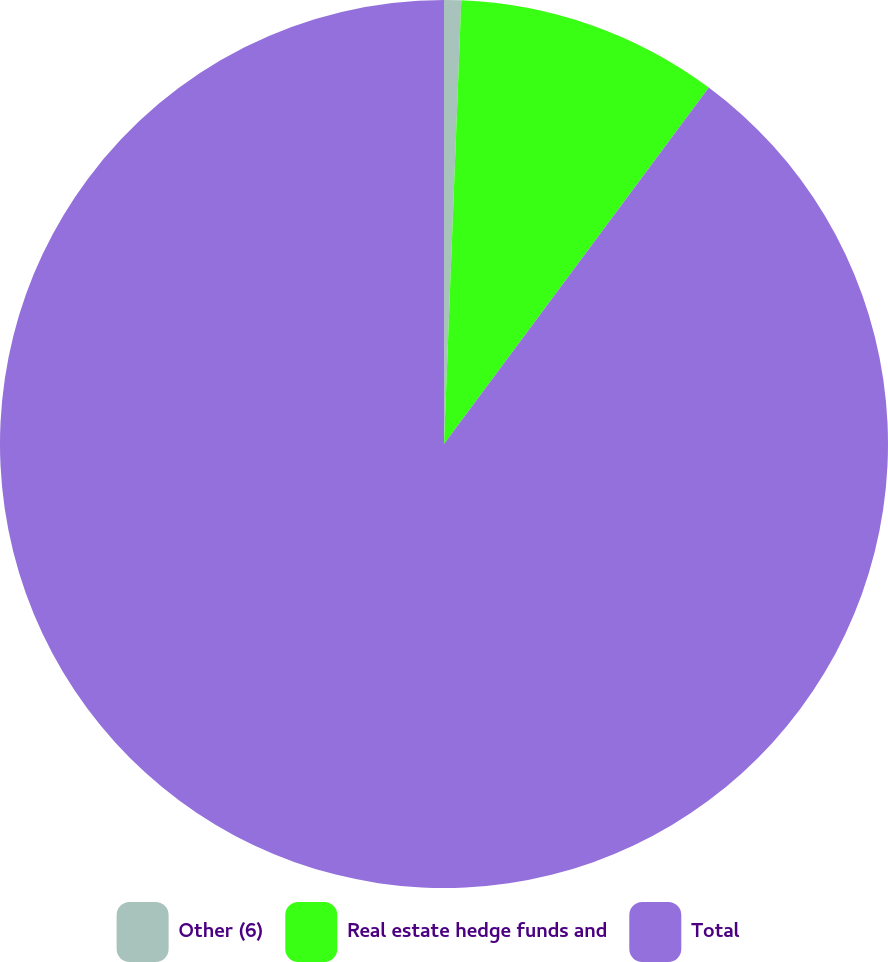Convert chart to OTSL. <chart><loc_0><loc_0><loc_500><loc_500><pie_chart><fcel>Other (6)<fcel>Real estate hedge funds and<fcel>Total<nl><fcel>0.62%<fcel>9.55%<fcel>89.83%<nl></chart> 